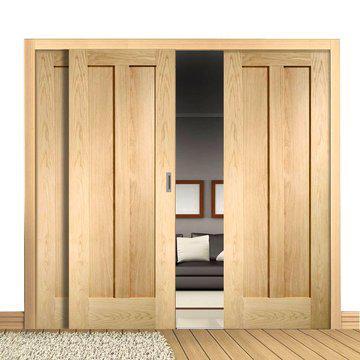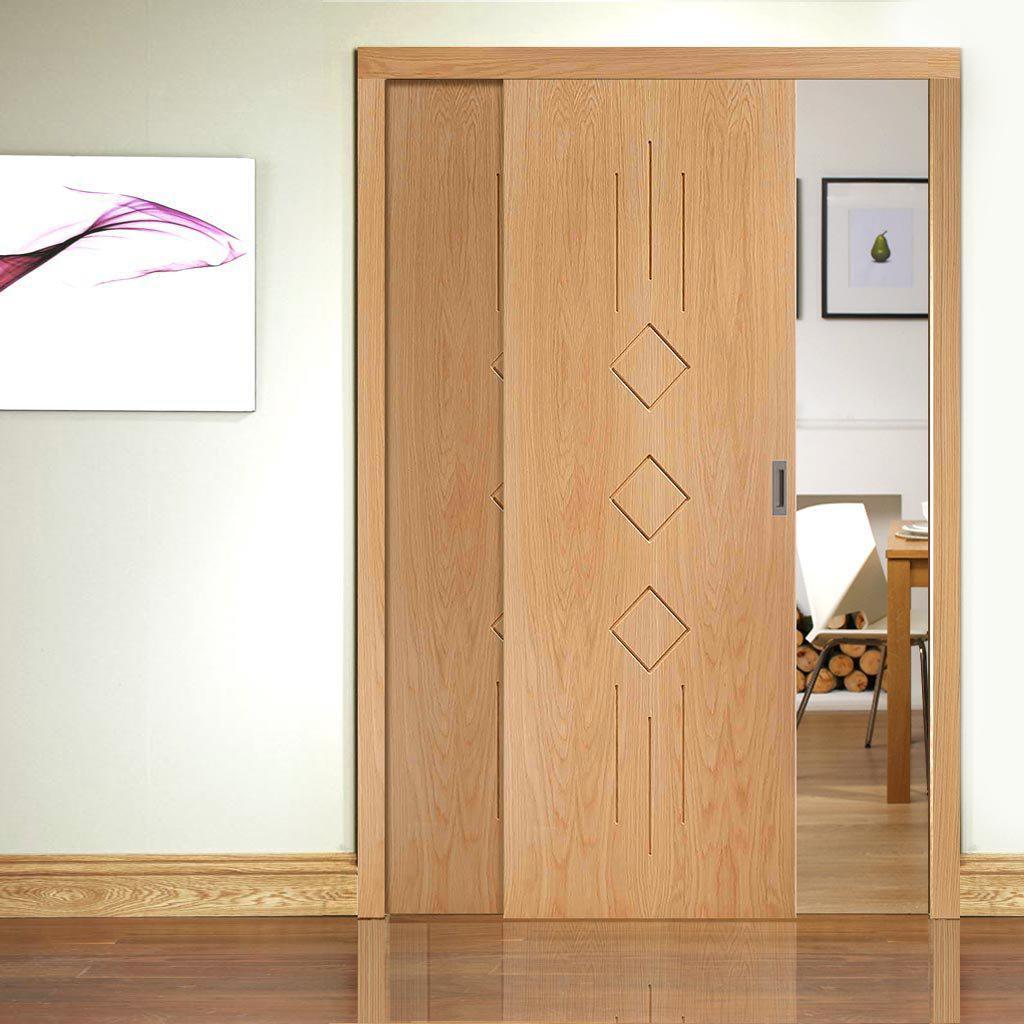The first image is the image on the left, the second image is the image on the right. Assess this claim about the two images: "In one image, a door leading to a room has two panels, one of them partially open.". Correct or not? Answer yes or no. Yes. The first image is the image on the left, the second image is the image on the right. Examine the images to the left and right. Is the description "At least one set of doors opens with a gap in the center." accurate? Answer yes or no. Yes. 